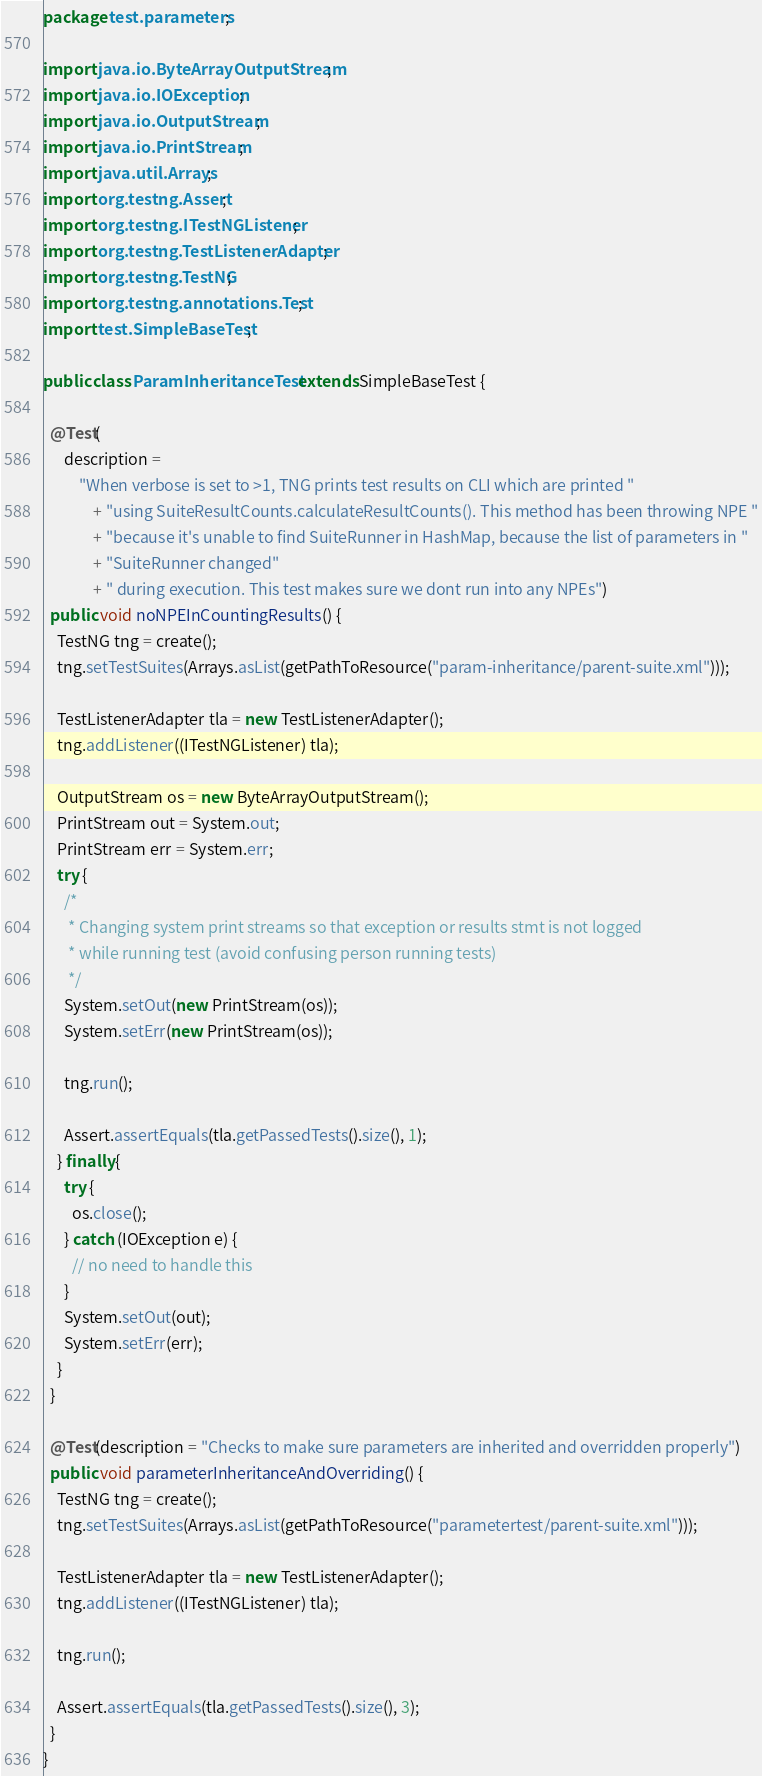<code> <loc_0><loc_0><loc_500><loc_500><_Java_>package test.parameters;

import java.io.ByteArrayOutputStream;
import java.io.IOException;
import java.io.OutputStream;
import java.io.PrintStream;
import java.util.Arrays;
import org.testng.Assert;
import org.testng.ITestNGListener;
import org.testng.TestListenerAdapter;
import org.testng.TestNG;
import org.testng.annotations.Test;
import test.SimpleBaseTest;

public class ParamInheritanceTest extends SimpleBaseTest {

  @Test(
      description =
          "When verbose is set to >1, TNG prints test results on CLI which are printed "
              + "using SuiteResultCounts.calculateResultCounts(). This method has been throwing NPE "
              + "because it's unable to find SuiteRunner in HashMap, because the list of parameters in "
              + "SuiteRunner changed"
              + " during execution. This test makes sure we dont run into any NPEs")
  public void noNPEInCountingResults() {
    TestNG tng = create();
    tng.setTestSuites(Arrays.asList(getPathToResource("param-inheritance/parent-suite.xml")));

    TestListenerAdapter tla = new TestListenerAdapter();
    tng.addListener((ITestNGListener) tla);

    OutputStream os = new ByteArrayOutputStream();
    PrintStream out = System.out;
    PrintStream err = System.err;
    try {
      /*
       * Changing system print streams so that exception or results stmt is not logged
       * while running test (avoid confusing person running tests)
       */
      System.setOut(new PrintStream(os));
      System.setErr(new PrintStream(os));

      tng.run();

      Assert.assertEquals(tla.getPassedTests().size(), 1);
    } finally {
      try {
        os.close();
      } catch (IOException e) {
        // no need to handle this
      }
      System.setOut(out);
      System.setErr(err);
    }
  }

  @Test(description = "Checks to make sure parameters are inherited and overridden properly")
  public void parameterInheritanceAndOverriding() {
    TestNG tng = create();
    tng.setTestSuites(Arrays.asList(getPathToResource("parametertest/parent-suite.xml")));

    TestListenerAdapter tla = new TestListenerAdapter();
    tng.addListener((ITestNGListener) tla);

    tng.run();

    Assert.assertEquals(tla.getPassedTests().size(), 3);
  }
}
</code> 